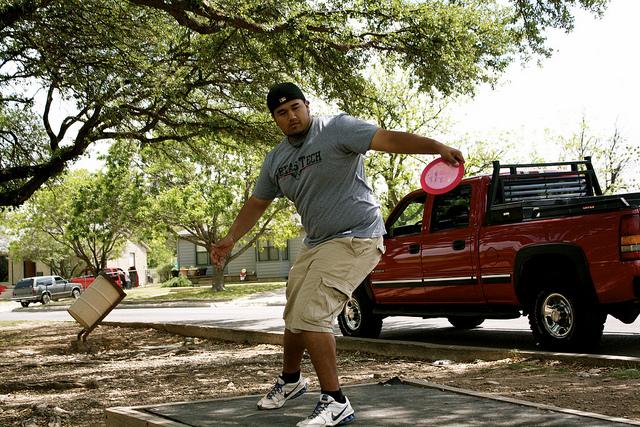What college does this man support?
Answer briefly. Texas tech. What's on the person's head?
Short answer required. Hat. Is the man going to throw the frisbee?
Answer briefly. Yes. 